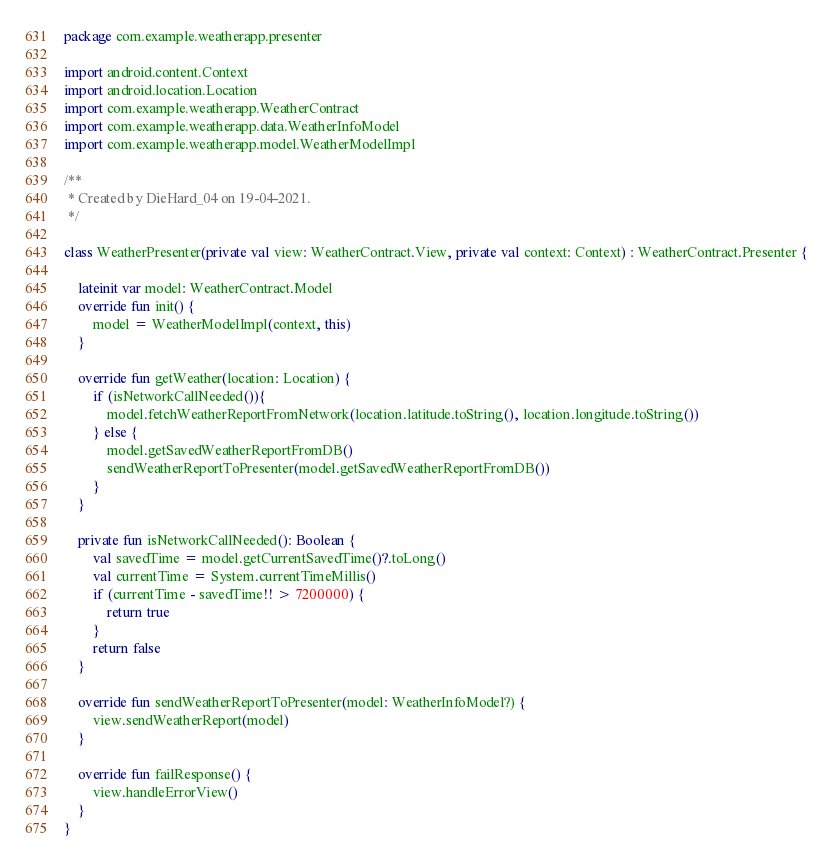<code> <loc_0><loc_0><loc_500><loc_500><_Kotlin_>package com.example.weatherapp.presenter

import android.content.Context
import android.location.Location
import com.example.weatherapp.WeatherContract
import com.example.weatherapp.data.WeatherInfoModel
import com.example.weatherapp.model.WeatherModelImpl

/**
 * Created by DieHard_04 on 19-04-2021.
 */

class WeatherPresenter(private val view: WeatherContract.View, private val context: Context) : WeatherContract.Presenter {

    lateinit var model: WeatherContract.Model
    override fun init() {
        model = WeatherModelImpl(context, this)
    }

    override fun getWeather(location: Location) {
        if (isNetworkCallNeeded()){
            model.fetchWeatherReportFromNetwork(location.latitude.toString(), location.longitude.toString())
        } else {
            model.getSavedWeatherReportFromDB()
            sendWeatherReportToPresenter(model.getSavedWeatherReportFromDB())
        }
    }

    private fun isNetworkCallNeeded(): Boolean {
        val savedTime = model.getCurrentSavedTime()?.toLong()
        val currentTime = System.currentTimeMillis()
        if (currentTime - savedTime!! > 7200000) {
            return true
        }
        return false
    }

    override fun sendWeatherReportToPresenter(model: WeatherInfoModel?) {
        view.sendWeatherReport(model)
    }

    override fun failResponse() {
        view.handleErrorView()
    }
}</code> 